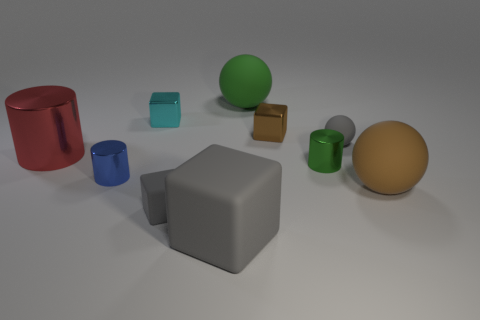Does the small gray rubber thing that is in front of the gray ball have the same shape as the gray matte thing on the right side of the green ball?
Your answer should be compact. No. There is a tiny matte thing that is the same color as the small rubber block; what is its shape?
Ensure brevity in your answer.  Sphere. How many green things are the same material as the green sphere?
Your response must be concise. 0. The small shiny object that is on the left side of the green metal cylinder and in front of the small gray matte ball has what shape?
Give a very brief answer. Cylinder. Is the brown object that is in front of the big red object made of the same material as the cyan block?
Your answer should be very brief. No. There is a matte block that is the same size as the red cylinder; what color is it?
Make the answer very short. Gray. Are there any large cubes of the same color as the tiny matte ball?
Give a very brief answer. Yes. There is a gray ball that is made of the same material as the large gray object; what is its size?
Ensure brevity in your answer.  Small. What size is the sphere that is the same color as the large rubber cube?
Your response must be concise. Small. How many other things are there of the same size as the cyan cube?
Provide a short and direct response. 5. 